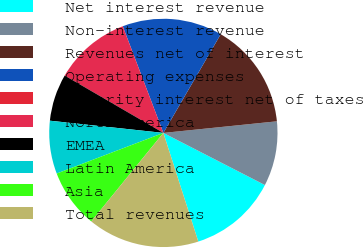Convert chart to OTSL. <chart><loc_0><loc_0><loc_500><loc_500><pie_chart><fcel>Net interest revenue<fcel>Non-interest revenue<fcel>Revenues net of interest<fcel>Operating expenses<fcel>Minority interest net of taxes<fcel>North America<fcel>EMEA<fcel>Latin America<fcel>Asia<fcel>Total revenues<nl><fcel>12.5%<fcel>9.17%<fcel>15.0%<fcel>14.17%<fcel>0.0%<fcel>10.83%<fcel>6.67%<fcel>7.5%<fcel>8.33%<fcel>15.83%<nl></chart> 